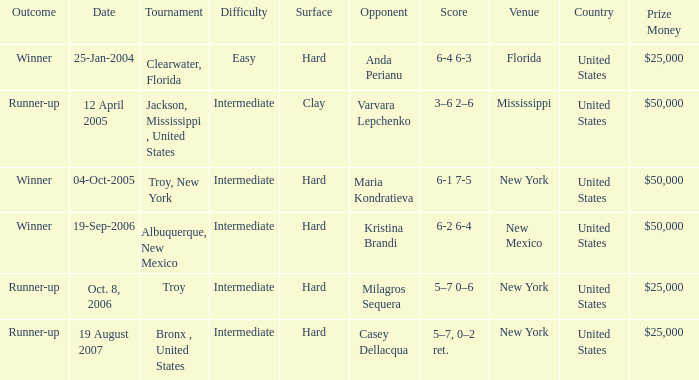What is the score of the game that was played against Maria Kondratieva? 6-1 7-5. 